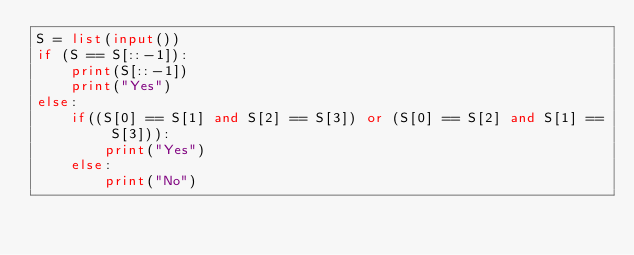<code> <loc_0><loc_0><loc_500><loc_500><_Python_>S = list(input())
if (S == S[::-1]):
    print(S[::-1])
    print("Yes")
else:
    if((S[0] == S[1] and S[2] == S[3]) or (S[0] == S[2] and S[1] == S[3])):
        print("Yes")
    else:
        print("No")</code> 